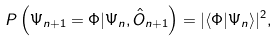<formula> <loc_0><loc_0><loc_500><loc_500>P \left ( \Psi _ { n + 1 } = \Phi | \Psi _ { n } , \hat { O } _ { n + 1 } \right ) = | \langle \Phi | \Psi _ { n } \rangle | ^ { 2 } ,</formula> 